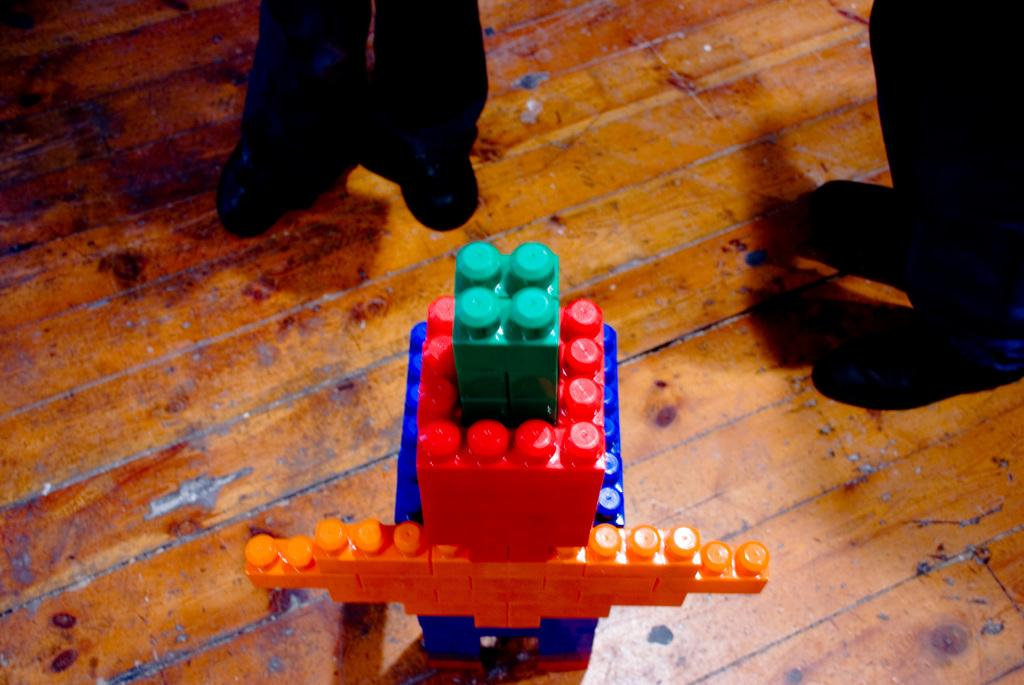What is the color of the floor in the image? The floor in the image is brown. What can be seen built with lego in the image? There is a structure made with lego in the image. Whose legs are visible in the image? The legs of two persons are visible in the image. What is the color of the legs in the image? The legs are black in color. What type of soap is being used to clean the lego structure in the image? There is no soap or cleaning activity depicted in the image; it only shows a lego structure and the legs of two persons. 